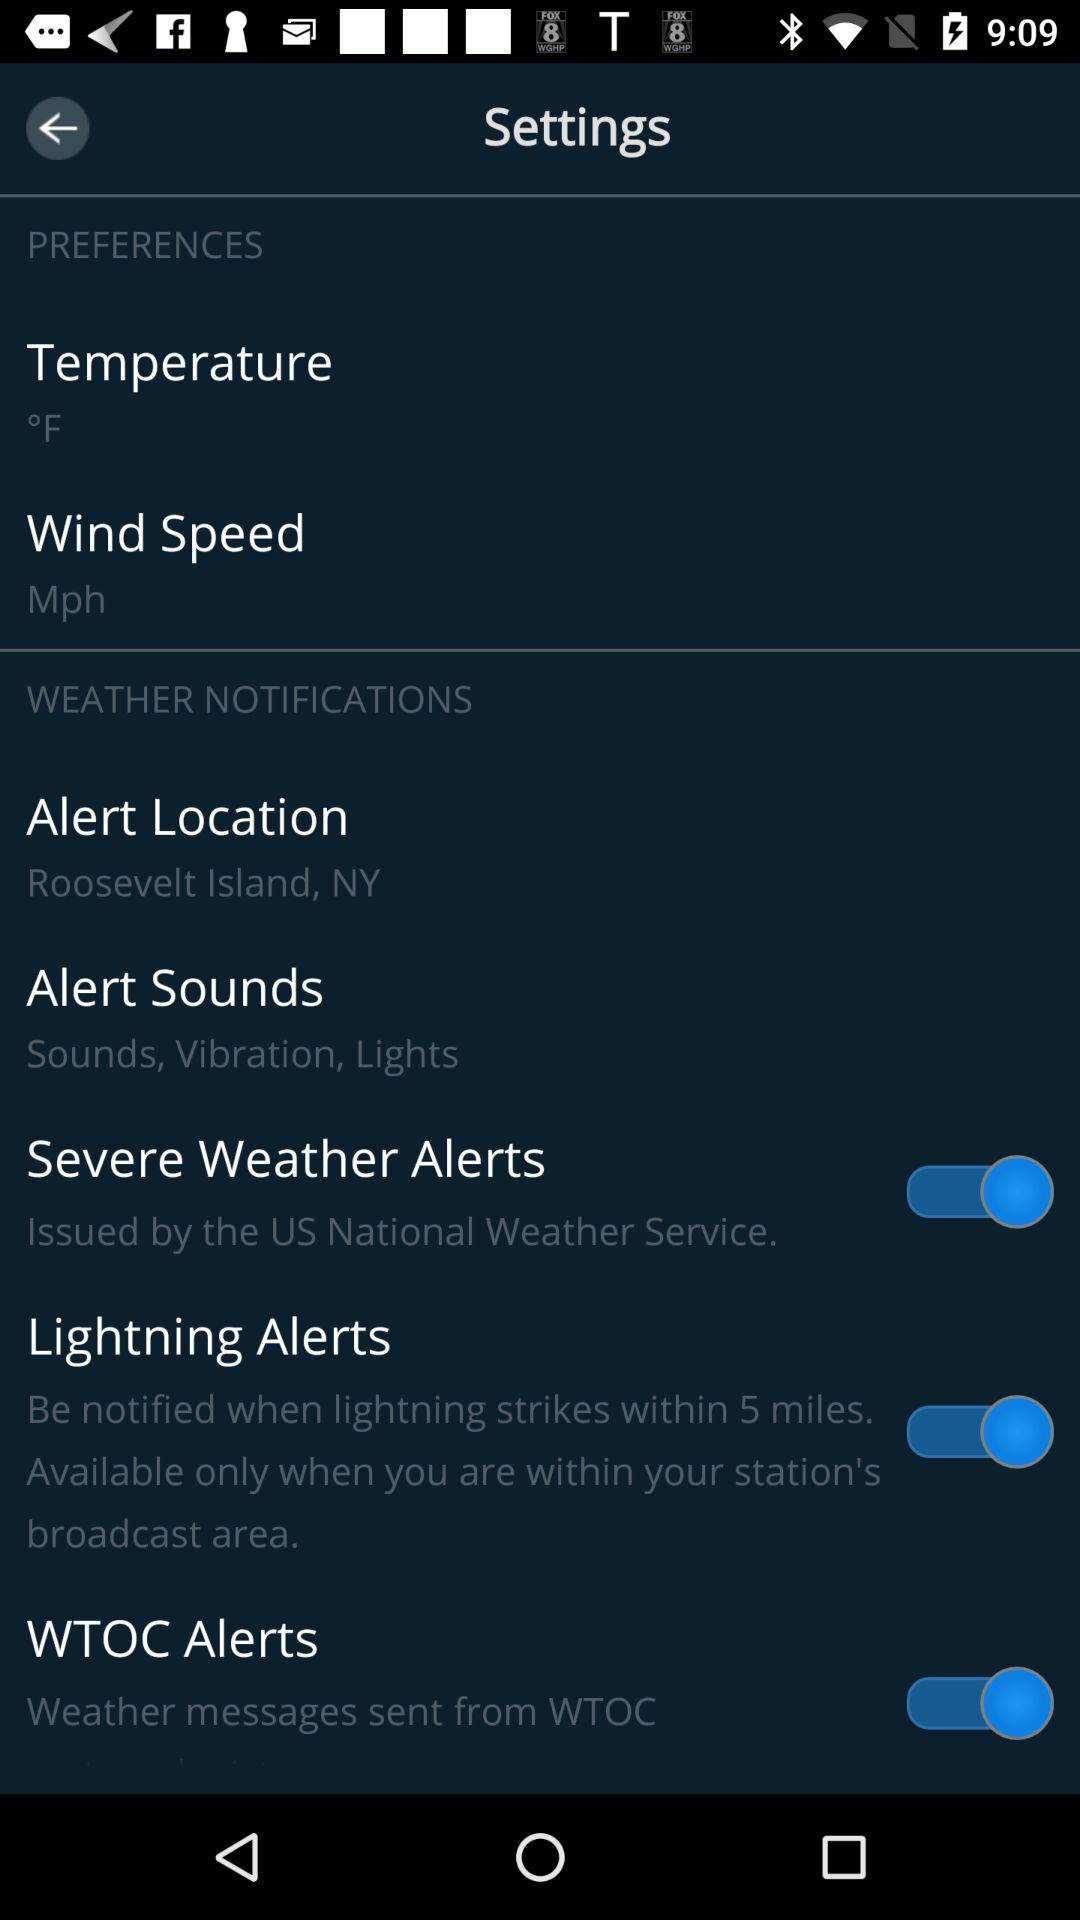What is the unit of temperature? The unit of temperature is °F. 